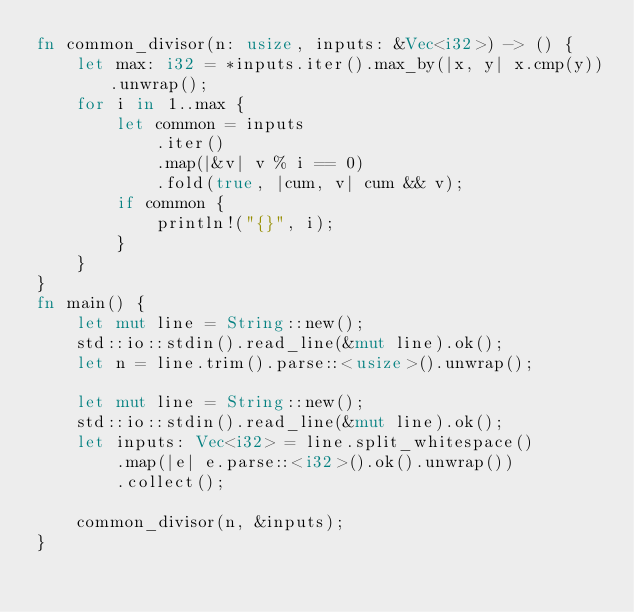<code> <loc_0><loc_0><loc_500><loc_500><_Rust_>fn common_divisor(n: usize, inputs: &Vec<i32>) -> () {
    let max: i32 = *inputs.iter().max_by(|x, y| x.cmp(y)).unwrap();
    for i in 1..max {
        let common = inputs
            .iter()
            .map(|&v| v % i == 0)
            .fold(true, |cum, v| cum && v);
        if common {
            println!("{}", i);
        }
    }
}
fn main() {
    let mut line = String::new();
    std::io::stdin().read_line(&mut line).ok();
    let n = line.trim().parse::<usize>().unwrap();

    let mut line = String::new();
    std::io::stdin().read_line(&mut line).ok();
    let inputs: Vec<i32> = line.split_whitespace()
        .map(|e| e.parse::<i32>().ok().unwrap())
        .collect();

    common_divisor(n, &inputs);
}

</code> 